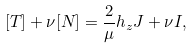Convert formula to latex. <formula><loc_0><loc_0><loc_500><loc_500>[ T ] + \nu [ N ] = \frac { 2 } { \mu } h _ { z } J + \nu I ,</formula> 